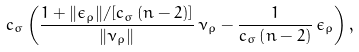Convert formula to latex. <formula><loc_0><loc_0><loc_500><loc_500>c _ { \sigma } \left ( \frac { 1 + \| \epsilon _ { \rho } \| / [ c _ { \sigma } \, ( n - 2 ) ] } { \| \nu _ { \rho } \| } \, \nu _ { \rho } - \frac { 1 } { c _ { \sigma } \left ( n - 2 \right ) } \, \epsilon _ { \rho } \right ) ,</formula> 